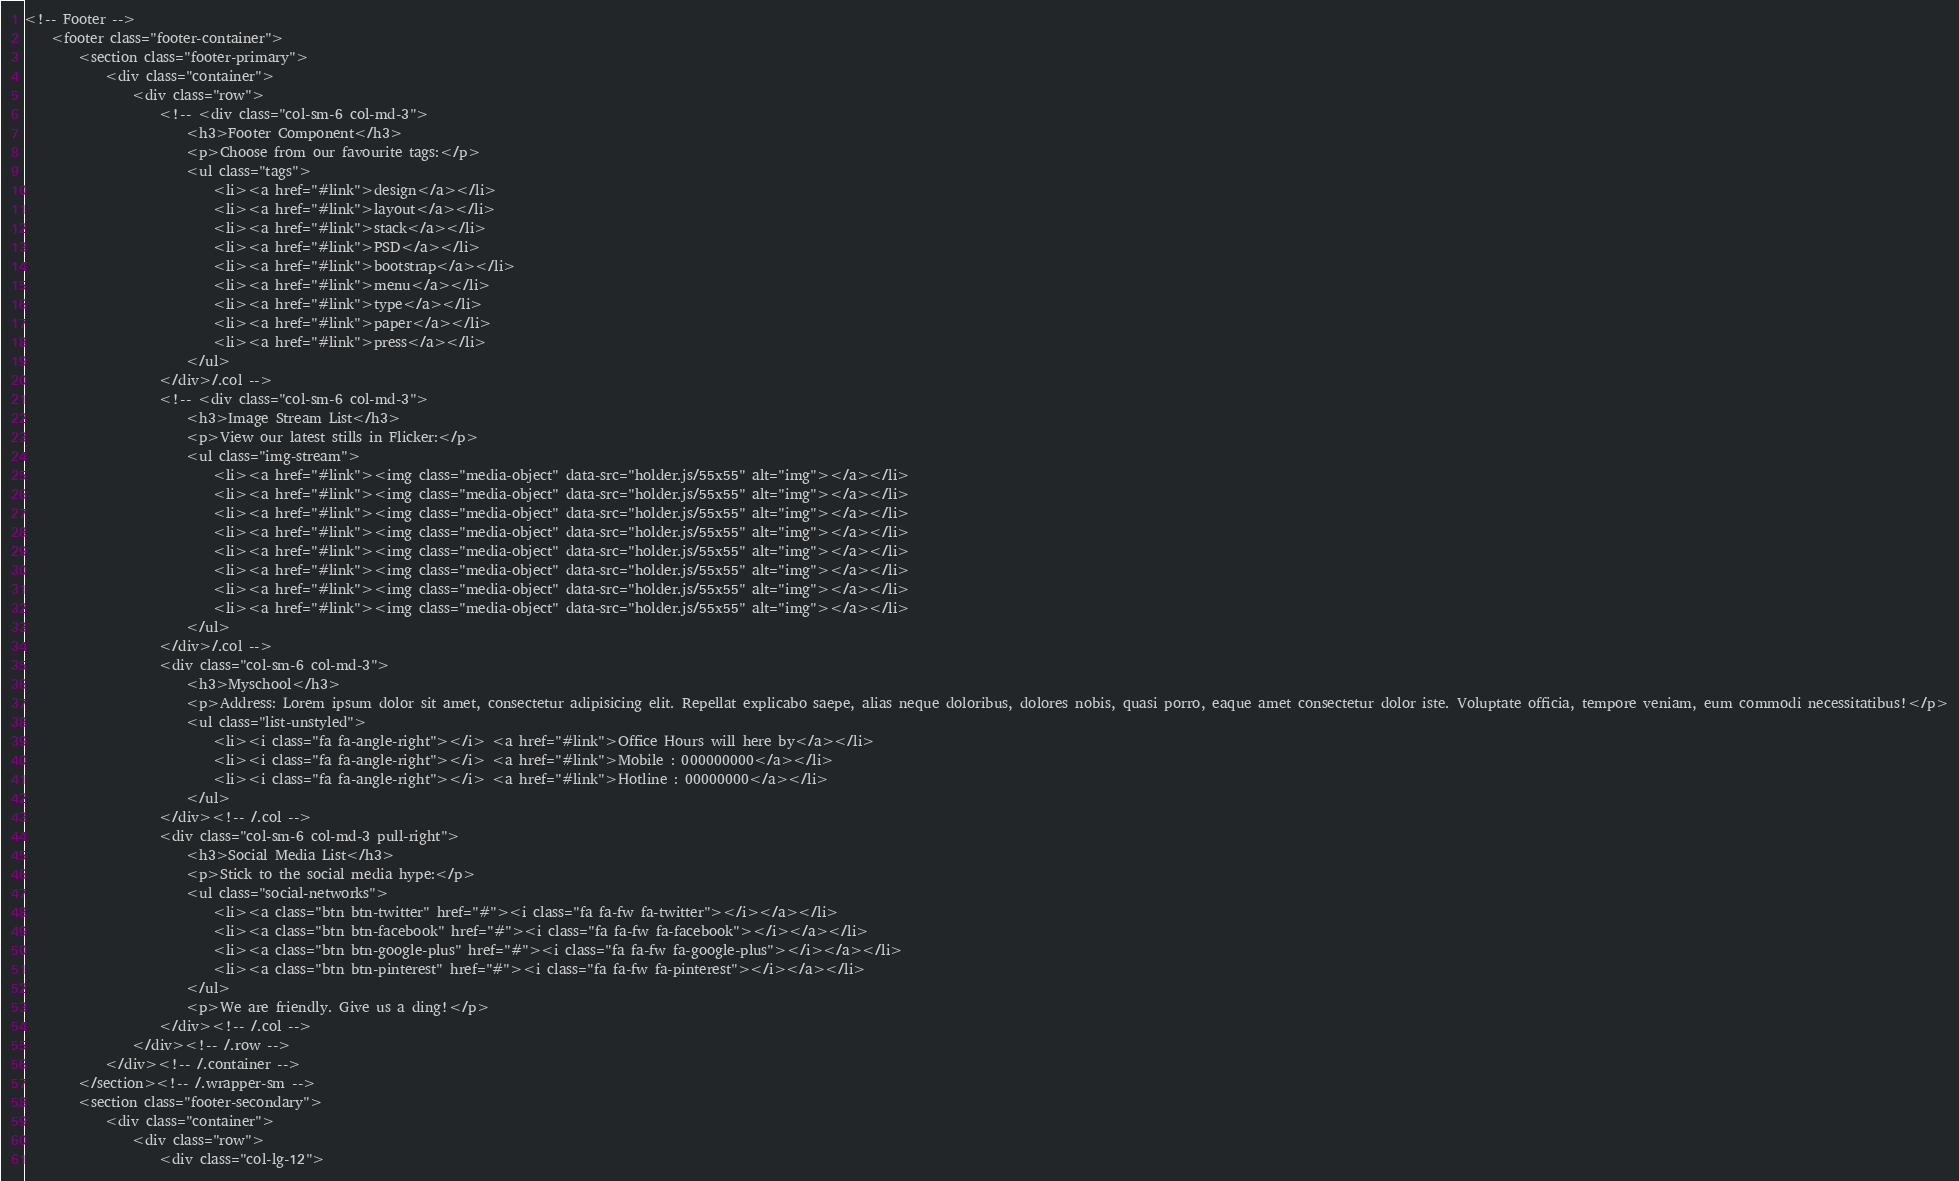<code> <loc_0><loc_0><loc_500><loc_500><_PHP_><!-- Footer -->
	<footer class="footer-container">
		<section class="footer-primary">
			<div class="container">
				<div class="row">
					<!-- <div class="col-sm-6 col-md-3">
						<h3>Footer Component</h3>
						<p>Choose from our favourite tags:</p>
						<ul class="tags">
							<li><a href="#link">design</a></li>
							<li><a href="#link">layout</a></li>
							<li><a href="#link">stack</a></li>
							<li><a href="#link">PSD</a></li>
							<li><a href="#link">bootstrap</a></li>
							<li><a href="#link">menu</a></li>
							<li><a href="#link">type</a></li>
							<li><a href="#link">paper</a></li>
							<li><a href="#link">press</a></li>
						</ul>
					</div>/.col -->
					<!-- <div class="col-sm-6 col-md-3">
						<h3>Image Stream List</h3>
						<p>View our latest stills in Flicker:</p>
						<ul class="img-stream">
							<li><a href="#link"><img class="media-object" data-src="holder.js/55x55" alt="img"></a></li>
							<li><a href="#link"><img class="media-object" data-src="holder.js/55x55" alt="img"></a></li>
							<li><a href="#link"><img class="media-object" data-src="holder.js/55x55" alt="img"></a></li>
							<li><a href="#link"><img class="media-object" data-src="holder.js/55x55" alt="img"></a></li>
							<li><a href="#link"><img class="media-object" data-src="holder.js/55x55" alt="img"></a></li>
							<li><a href="#link"><img class="media-object" data-src="holder.js/55x55" alt="img"></a></li>
							<li><a href="#link"><img class="media-object" data-src="holder.js/55x55" alt="img"></a></li>
							<li><a href="#link"><img class="media-object" data-src="holder.js/55x55" alt="img"></a></li>
						</ul>
					</div>/.col -->
					<div class="col-sm-6 col-md-3">
						<h3>Myschool</h3>
						<p>Address: Lorem ipsum dolor sit amet, consectetur adipisicing elit. Repellat explicabo saepe, alias neque doloribus, dolores nobis, quasi porro, eaque amet consectetur dolor iste. Voluptate officia, tempore veniam, eum commodi necessitatibus!</p>
						<ul class="list-unstyled">
							<li><i class="fa fa-angle-right"></i> <a href="#link">Office Hours will here by</a></li>
							<li><i class="fa fa-angle-right"></i> <a href="#link">Mobile : 000000000</a></li>
							<li><i class="fa fa-angle-right"></i> <a href="#link">Hotline : 00000000</a></li>
						</ul>
					</div><!-- /.col -->
					<div class="col-sm-6 col-md-3 pull-right">
						<h3>Social Media List</h3>
						<p>Stick to the social media hype:</p>
						<ul class="social-networks">
							<li><a class="btn btn-twitter" href="#"><i class="fa fa-fw fa-twitter"></i></a></li>
							<li><a class="btn btn-facebook" href="#"><i class="fa fa-fw fa-facebook"></i></a></li>
							<li><a class="btn btn-google-plus" href="#"><i class="fa fa-fw fa-google-plus"></i></a></li>
							<li><a class="btn btn-pinterest" href="#"><i class="fa fa-fw fa-pinterest"></i></a></li>
						</ul>
						<p>We are friendly. Give us a ding!</p>
					</div><!-- /.col -->
				</div><!-- /.row -->
			</div><!-- /.container -->
		</section><!-- /.wrapper-sm -->
		<section class="footer-secondary">
			<div class="container">
				<div class="row">
					<div class="col-lg-12"></code> 